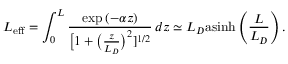<formula> <loc_0><loc_0><loc_500><loc_500>L _ { e f f } = \int _ { 0 } ^ { L } \frac { \exp { ( - \alpha z ) } } { \Big [ 1 + \Big ( \frac { z } { L _ { D } } \Big ) ^ { 2 } ] ^ { 1 / 2 } } \, d z \simeq L _ { D } a \sinh \left ( \frac { L } { L _ { D } } \right ) .</formula> 